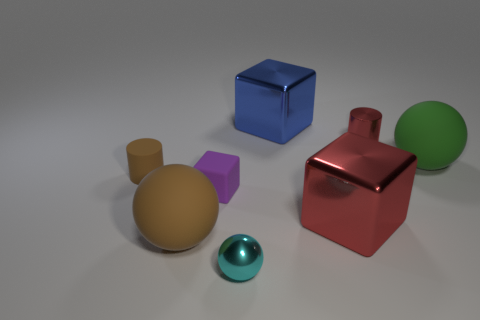Subtract all large green spheres. How many spheres are left? 2 Add 2 big brown blocks. How many objects exist? 10 Subtract 1 spheres. How many spheres are left? 2 Subtract all balls. How many objects are left? 5 Add 5 purple cubes. How many purple cubes exist? 6 Subtract 0 red spheres. How many objects are left? 8 Subtract all red cylinders. Subtract all purple balls. How many cylinders are left? 1 Subtract all blocks. Subtract all big green metal balls. How many objects are left? 5 Add 3 tiny cyan spheres. How many tiny cyan spheres are left? 4 